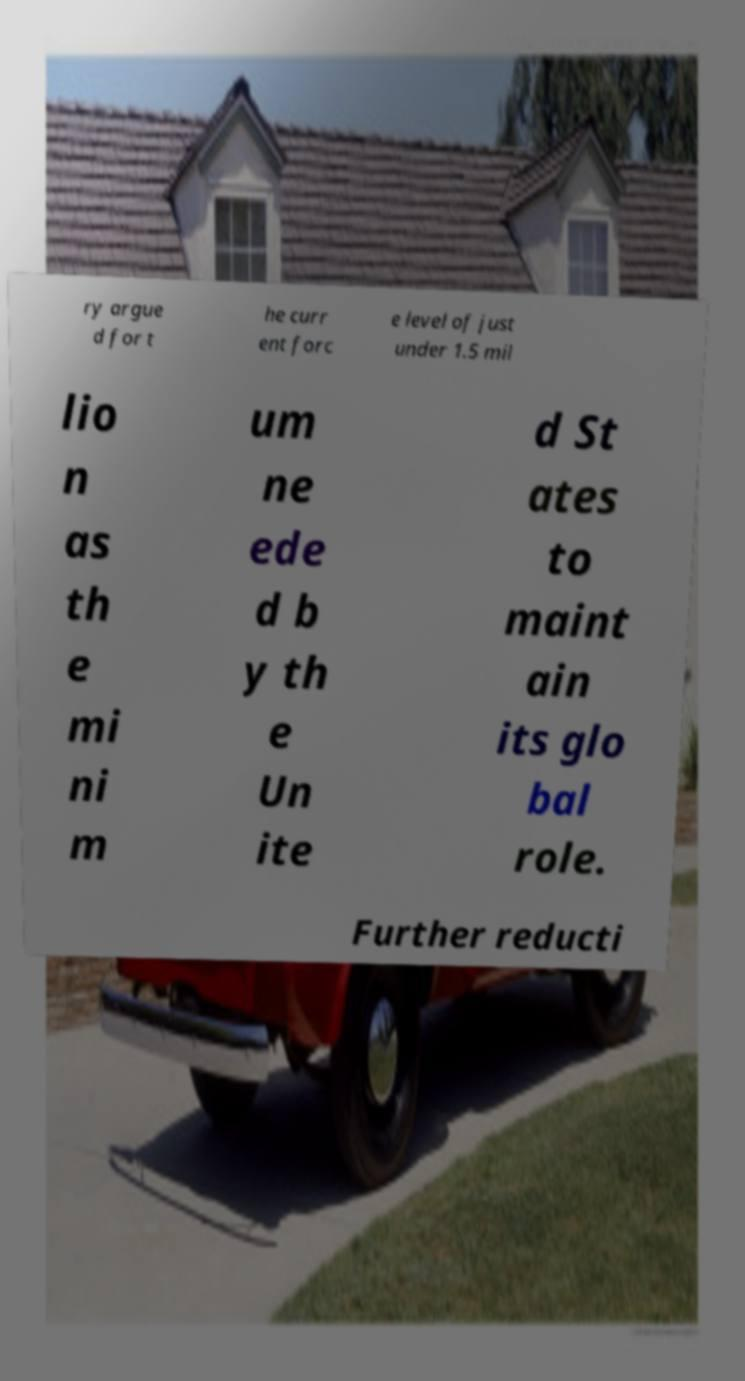There's text embedded in this image that I need extracted. Can you transcribe it verbatim? ry argue d for t he curr ent forc e level of just under 1.5 mil lio n as th e mi ni m um ne ede d b y th e Un ite d St ates to maint ain its glo bal role. Further reducti 